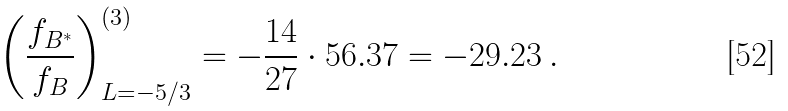Convert formula to latex. <formula><loc_0><loc_0><loc_500><loc_500>\left ( \frac { f _ { B ^ { * } } } { f _ { B } } \right ) ^ { ( 3 ) } _ { L = - 5 / 3 } = - \frac { 1 4 } { 2 7 } \cdot 5 6 . 3 7 = - 2 9 . 2 3 \, .</formula> 